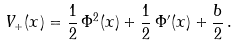<formula> <loc_0><loc_0><loc_500><loc_500>V _ { + } ( x ) = \frac { 1 } { 2 } \, \Phi ^ { 2 } ( x ) + \frac { 1 } { 2 } \, \Phi ^ { \prime } ( x ) + \frac { b } { 2 } \, .</formula> 